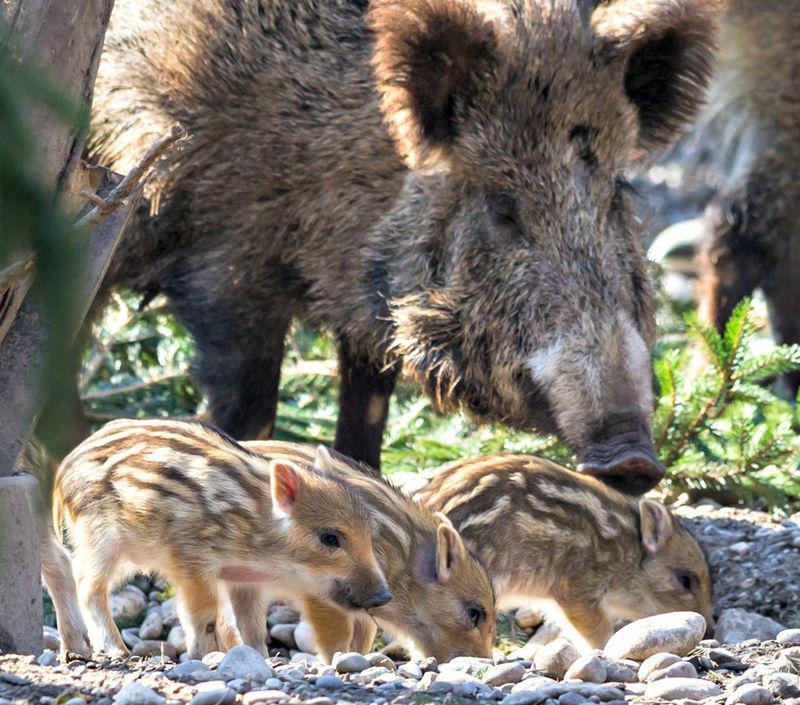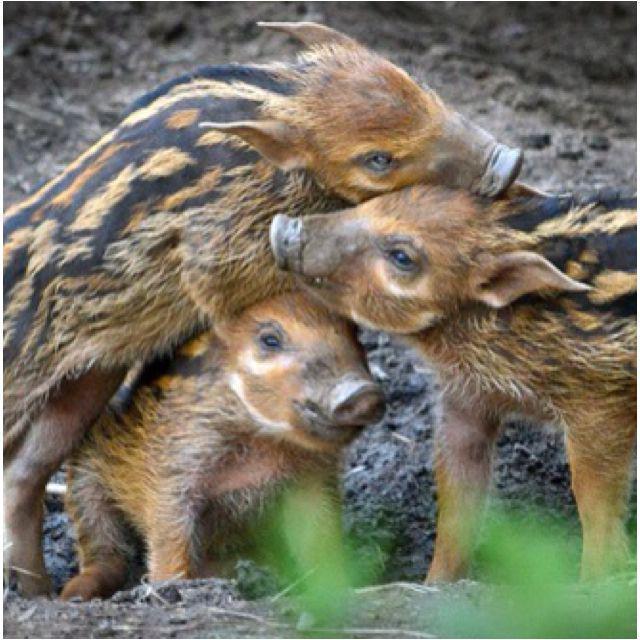The first image is the image on the left, the second image is the image on the right. Considering the images on both sides, is "An image contains only young hogs, all without distinctive patterned fur." valid? Answer yes or no. No. The first image is the image on the left, the second image is the image on the right. Analyze the images presented: Is the assertion "There are no more than 3 hogs in total." valid? Answer yes or no. No. 